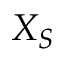Convert formula to latex. <formula><loc_0><loc_0><loc_500><loc_500>X _ { S }</formula> 